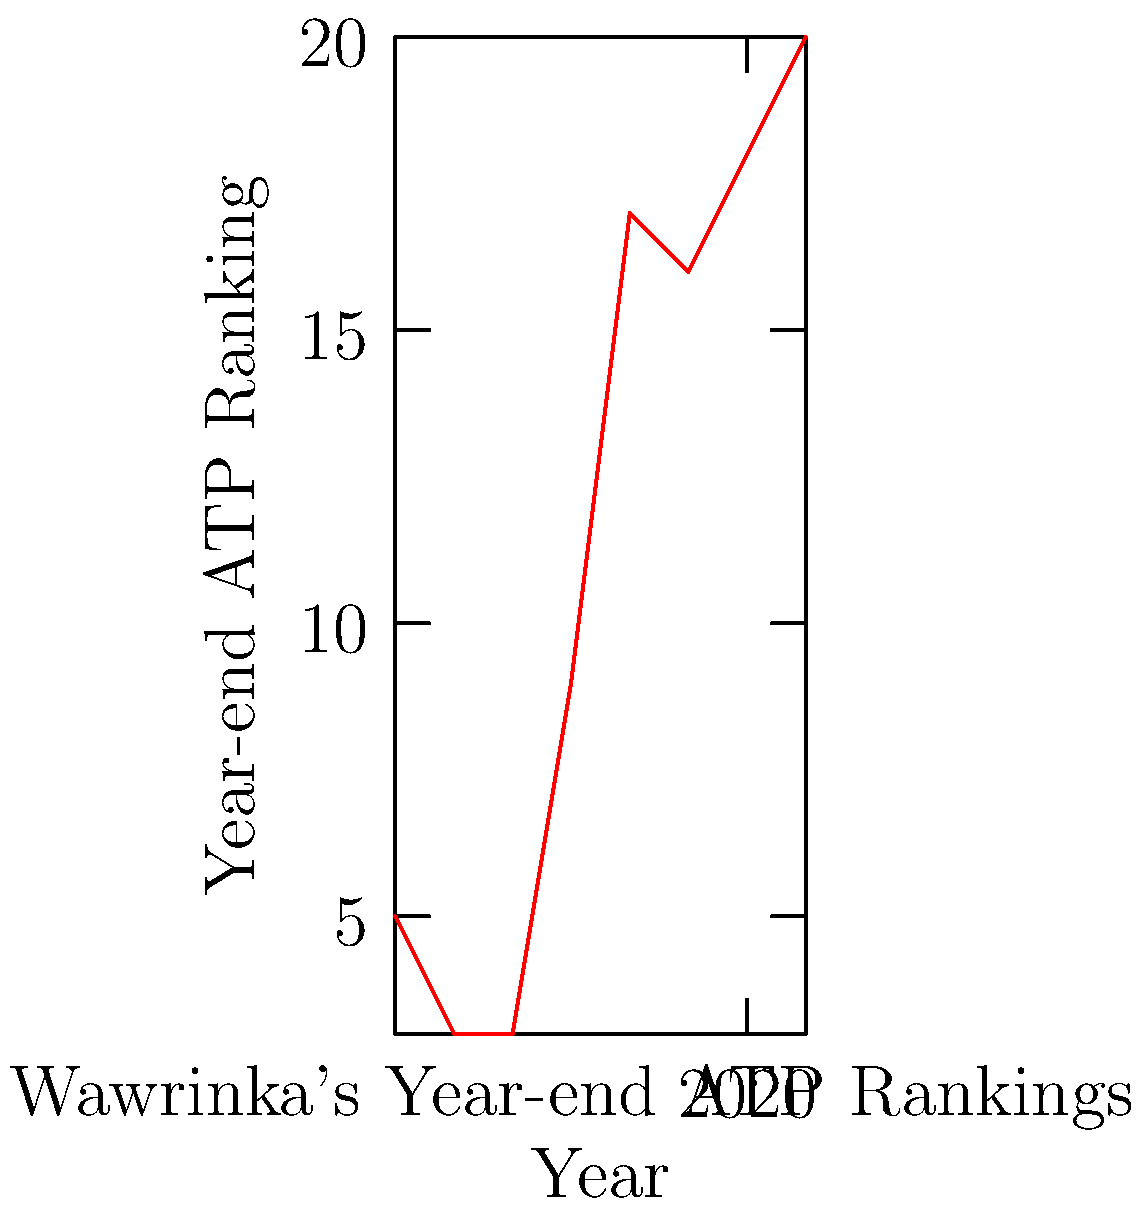Based on the line graph showing Stan Wawrinka's year-end ATP rankings from 2014 to 2021, in which year did Wawrinka achieve his highest ranking during this period? To determine the year when Stan Wawrinka achieved his highest ranking, we need to follow these steps:

1. Understand that a lower number in ATP ranking indicates a better performance.
2. Scan the graph from left to right, noting the lowest point on the line.
3. Observe that the line starts low in 2014 and generally trends upward (indicating lower rankings) over time.
4. The lowest point on the graph corresponds to the highest ranking.
5. This lowest point occurs in 2015, indicating Wawrinka's highest ranking in the given period.

Therefore, Stan Wawrinka achieved his highest ranking in 2015 during the period shown in the graph.
Answer: 2015 